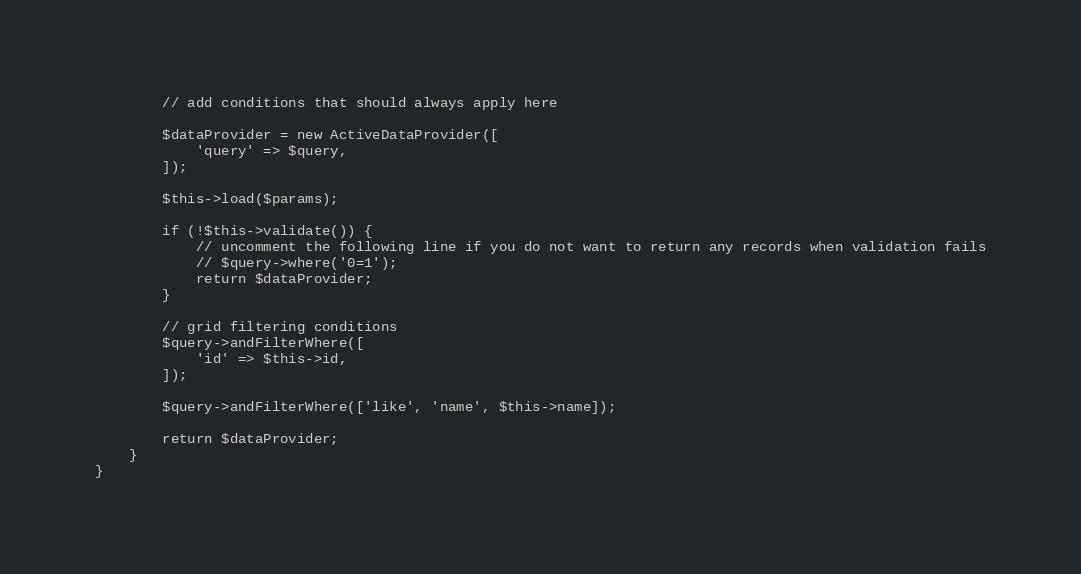Convert code to text. <code><loc_0><loc_0><loc_500><loc_500><_PHP_>        // add conditions that should always apply here

        $dataProvider = new ActiveDataProvider([
            'query' => $query,
        ]);

        $this->load($params);

        if (!$this->validate()) {
            // uncomment the following line if you do not want to return any records when validation fails
            // $query->where('0=1');
            return $dataProvider;
        }

        // grid filtering conditions
        $query->andFilterWhere([
            'id' => $this->id,
        ]);

        $query->andFilterWhere(['like', 'name', $this->name]);

        return $dataProvider;
    }
}
</code> 